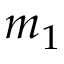Convert formula to latex. <formula><loc_0><loc_0><loc_500><loc_500>m _ { 1 }</formula> 